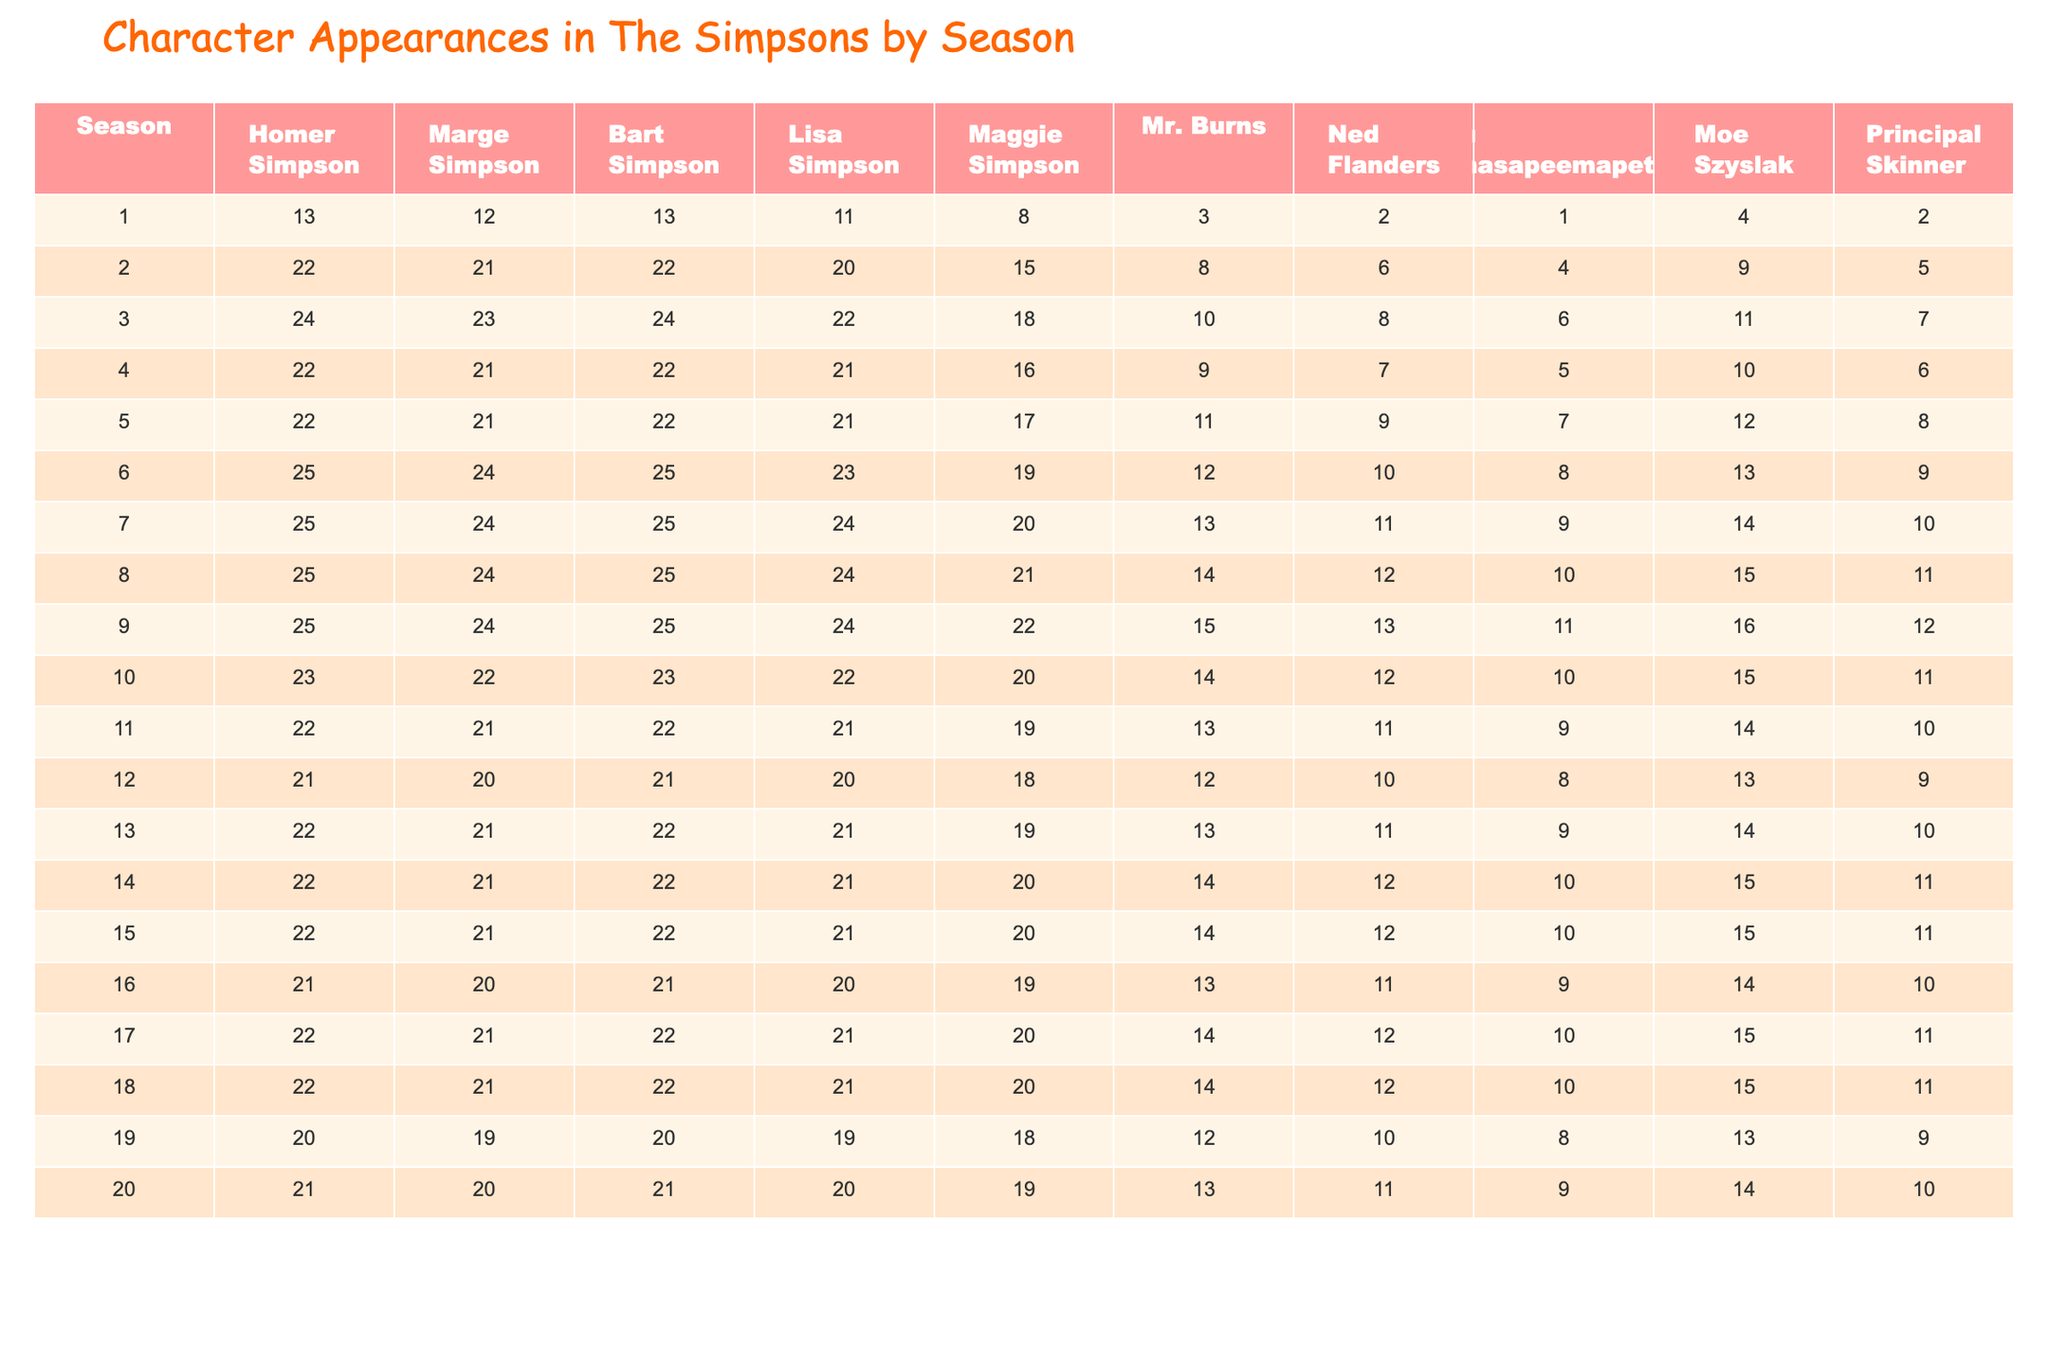What is the highest number of appearances for Homer Simpson in a season? Looking at the table, the highest number of appearances for Homer Simpson is 25, which occurs in seasons 6, 7, 8, and 9.
Answer: 25 Which character had the fewest appearances in season 1? The table shows that in season 1, Apu Nahasapeemapetilon had the fewest appearances, with only 1.
Answer: 1 How many more appearances did Lisa Simpson have compared to Maggie Simpson in season 10? In season 10, Lisa Simpson had 22 appearances, while Maggie Simpson had 15. The difference is 22 - 15 = 7.
Answer: 7 In which season did Mr. Burns appear the most? Mr. Burns had his highest appearance count of 20 in season 18.
Answer: 20 What is the average number of appearances for Ned Flanders across all seasons? To calculate the average, sum all of Ned Flanders' appearances (which are 2, 8, 10, 9, 11, 13, 14, 15, 13, 9, 10, 12, 14, 14, 14, 13, 14, 14, 12, 13), which equals 283, then divide by 20 seasons. The average is 283 / 20 = 14.15, rounded to 14.
Answer: 14 Did Bart Simpson have more appearances in season 3 than in season 11? Bart Simpson had 24 appearances in season 3 and 22 in season 11. Since 24 is greater than 22, the answer is yes.
Answer: Yes Which character had consistent appearances of 22 in the first 10 seasons? Both Bart Simpson and Lisa Simpson had appearances of 22 in seasons 3, 4, 5, and 10 consistently, as seen in the table.
Answer: Bart and Lisa How many appearances did Apu Nahasapeemapetilon have in the entire series? Adding Apu's appearances across all seasons: 1 + 6 + 8 + 7 + 9 + 10 + 11 + 13 + 12 + 12 + 11 + 10 + 11 + 12 + 12 + 12 + 10 + 10 + 8 + 11 = 191.
Answer: 191 In which season did Marge Simpson have her lowest number of appearances? Marge Simpson had her lowest number of appearances in season 12, with only 20.
Answer: 20 What is the difference in total appearances between Homer and Marge Simpson across all seasons? Total appearances: Homer = 408, Marge = 392. The difference is 408 - 392 = 16.
Answer: 16 